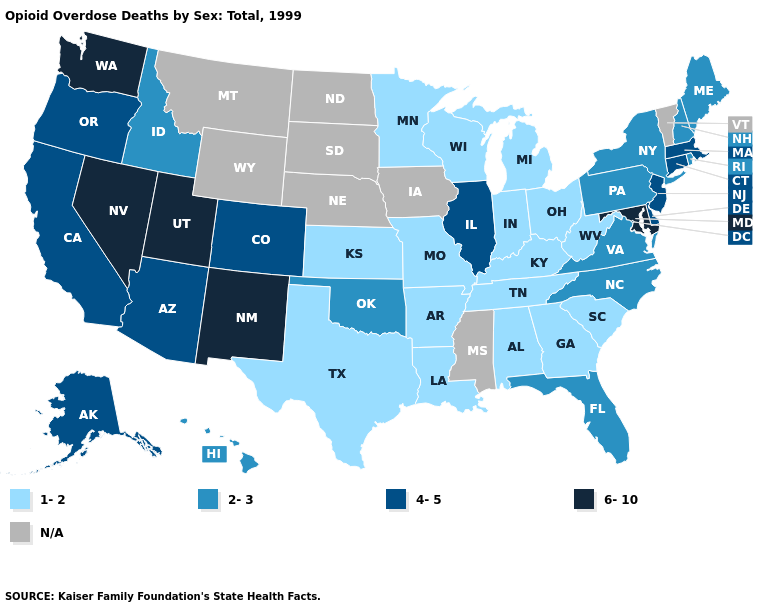Is the legend a continuous bar?
Be succinct. No. What is the value of Alaska?
Be succinct. 4-5. What is the lowest value in the MidWest?
Keep it brief. 1-2. Does Missouri have the highest value in the USA?
Keep it brief. No. Does Illinois have the lowest value in the MidWest?
Concise answer only. No. What is the value of North Dakota?
Keep it brief. N/A. What is the highest value in states that border Wisconsin?
Answer briefly. 4-5. Does Utah have the highest value in the USA?
Quick response, please. Yes. What is the lowest value in the USA?
Keep it brief. 1-2. Does North Carolina have the highest value in the USA?
Quick response, please. No. Is the legend a continuous bar?
Be succinct. No. Among the states that border Tennessee , which have the highest value?
Answer briefly. North Carolina, Virginia. 